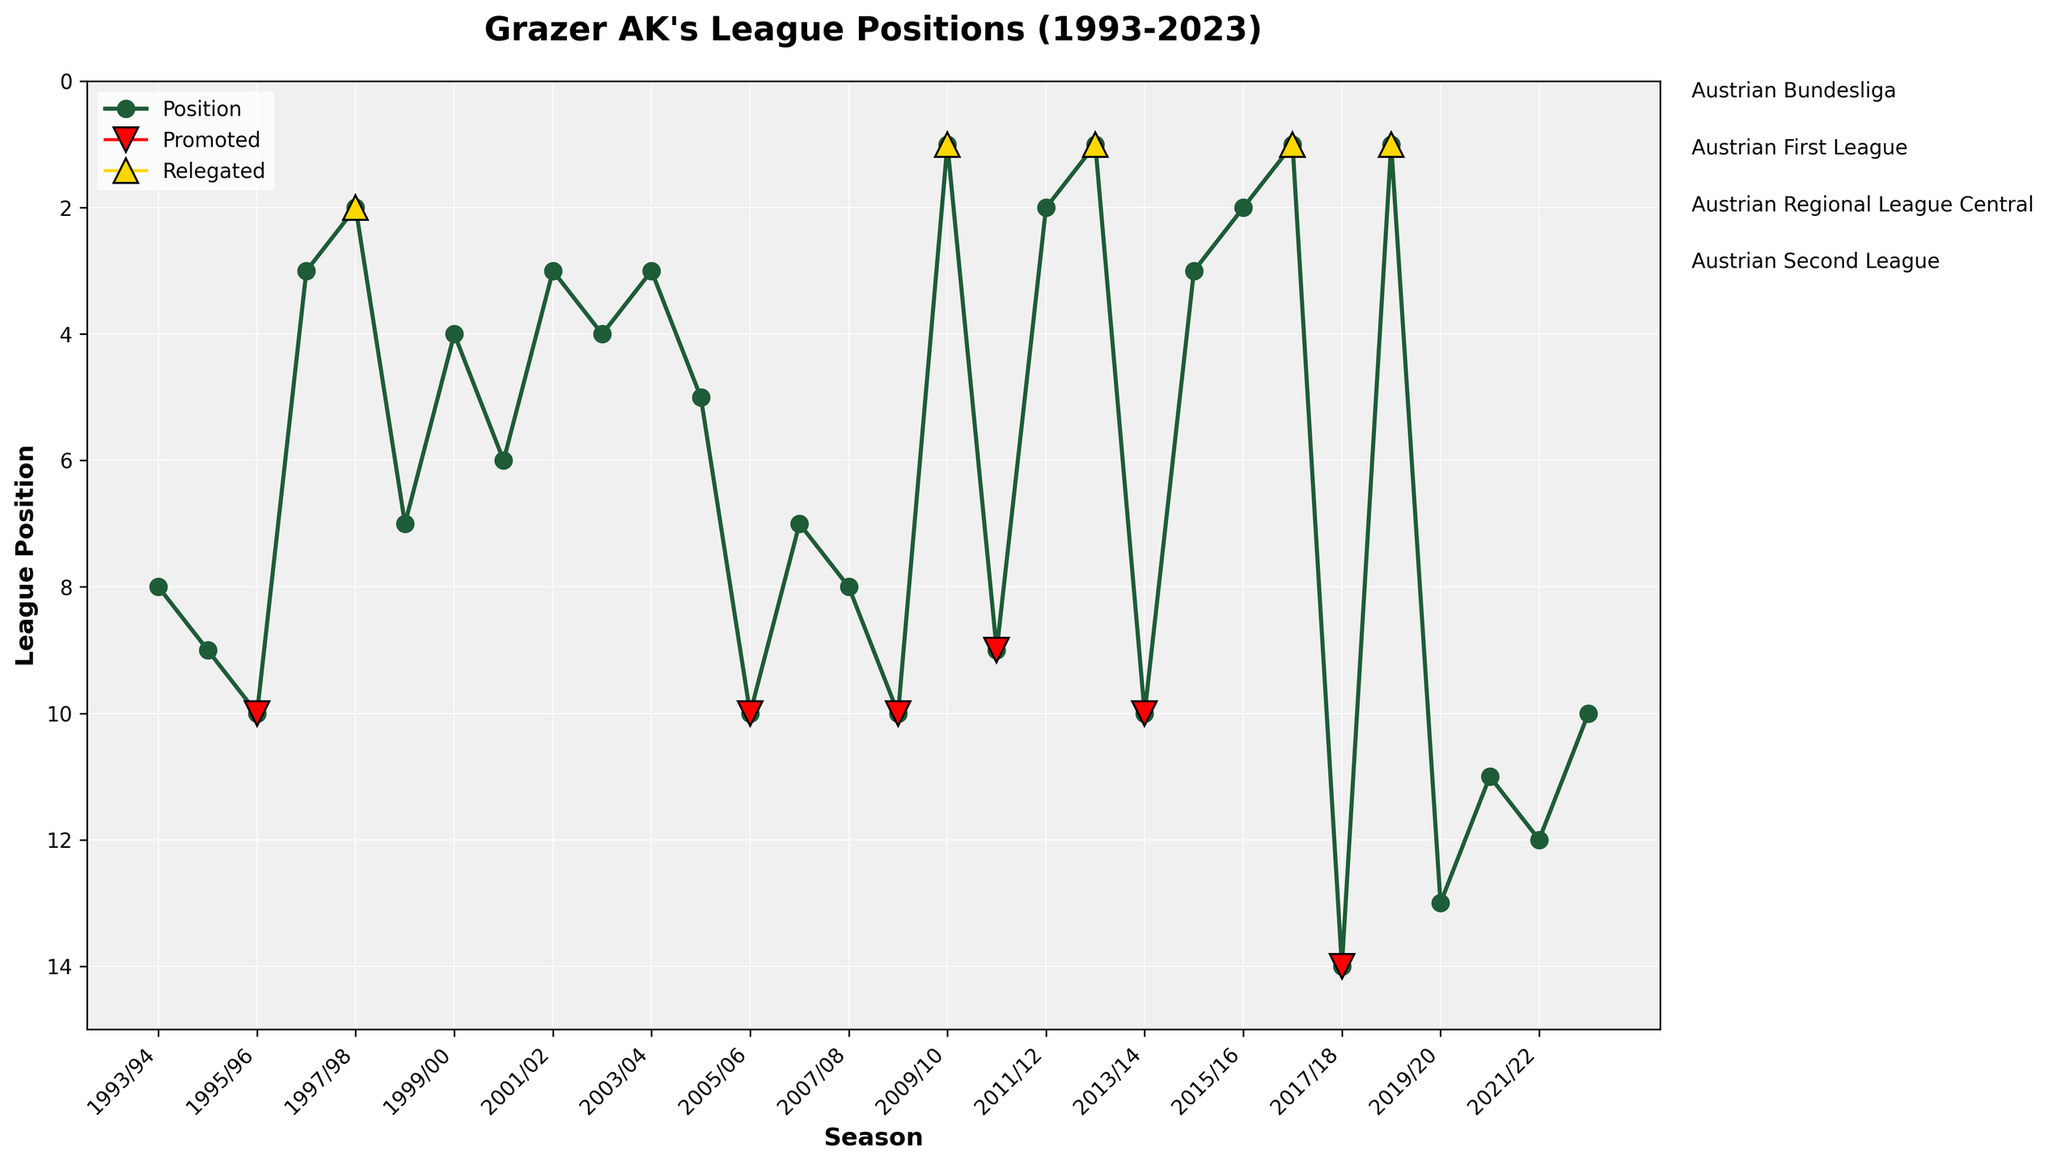What's the highest league position Grazer AK achieved in the Austrian Bundesliga? The highest position is the lowest numerical value on the y-axis in the Bundesliga section. In 2003/04 and 2001/02, they were 3rd.
Answer: 3rd How many times was Grazer AK relegated between 1993 and 2023? Relegations can be identified by red downward-facing triangles. Counting these, we see relegations in 1995/96, 2005/06, 2008/09, 2010/11, 2013/14, and 2017/18.
Answer: 6 In which season did Grazer AK get promoted back to the Austrian Bundesliga after their relegation in 1995/96? After their relegation in 1995/96, they were promoted back to the Bundesliga in the 1997/98 season, marked by a gold upward-facing triangle.
Answer: 1997/98 Compare the average league position of Grazer AK in the Austrian First League and the Austrian Second League. Calculating the average for the First League: (3 + 2 + 7 + 8 + 10 + 9 + 13 + 11 + 12 + 10)/10 = 8.5. For the Second League: (13 + 11 + 12 + 10) = 11.5.
Answer: 8.5 in the First League, 11.5 in the Second League During which periods did Grazer AK have the longest continuous stay in the Austrian Bundesliga? By observing continuous horizontal placement of league positions within the Bundesliga section, the longest continuous period starts from 1998/99 and ends at 2005/06, lasting 8 seasons.
Answer: 1998/99 to 2005/06 How often did Grazer AK finish in 10th position throughout the displayed seasons? The '10th' positions are marked at several points: 1995/96, 2005/06, 2008/09, 2013/14.
Answer: 4 times What is the median league position for Grazer AK in the 30 seasons shown? List all positions and find the middle one since there are 30 entries: sorting positions, the median (15th and 16th when ordered) are 7 and 8. So, the median is (7+8)/2 = 7.5.
Answer: 7.5 Compare Grazer AK's best and worst positions in the Austrian Regional League Central. The best position is 1st (2009/10, 2012/13, 2016/17, 2018/19) and the worst is 3rd (2011/12, 2014/15).
Answer: Best: 1st, Worst: 3rd How many times did Grazer AK achieve a top 3 finish across all leagues in the given period? Identify '1', '2,' and '3' positions: 2001/02, 2003/04, 2011/12, 2015/16-2016/17, 2018/19 count as top 3 finishes.
Answer: 8 times During which season did Grazer AK have the largest jump in position compared to the previous season? The largest jump can be seen between two consecutive seasons by observing the biggest vertical movement: 2008/09 (10) to 2009/10 (1) is a jump of 9 places.
Answer: 2008/09 to 2009/10 